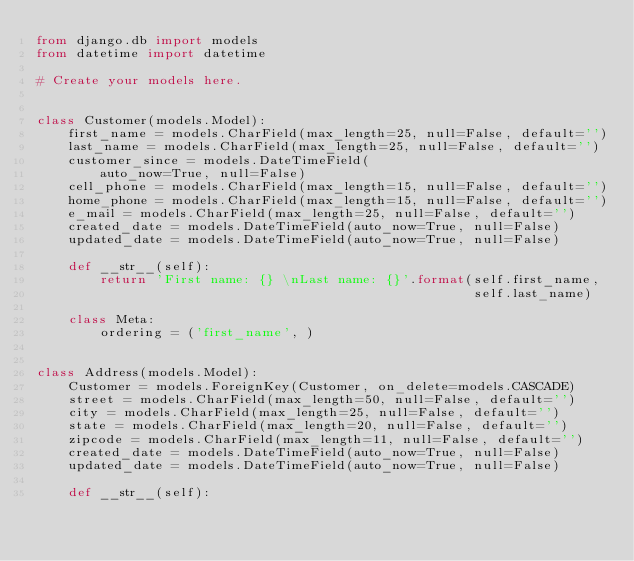<code> <loc_0><loc_0><loc_500><loc_500><_Python_>from django.db import models
from datetime import datetime

# Create your models here.


class Customer(models.Model):
    first_name = models.CharField(max_length=25, null=False, default='')
    last_name = models.CharField(max_length=25, null=False, default='')
    customer_since = models.DateTimeField(
        auto_now=True, null=False)
    cell_phone = models.CharField(max_length=15, null=False, default='')
    home_phone = models.CharField(max_length=15, null=False, default='')
    e_mail = models.CharField(max_length=25, null=False, default='')
    created_date = models.DateTimeField(auto_now=True, null=False)
    updated_date = models.DateTimeField(auto_now=True, null=False)

    def __str__(self):
        return 'First name: {} \nLast name: {}'.format(self.first_name,
                                                       self.last_name)

    class Meta:
        ordering = ('first_name', )


class Address(models.Model):
    Customer = models.ForeignKey(Customer, on_delete=models.CASCADE)
    street = models.CharField(max_length=50, null=False, default='')
    city = models.CharField(max_length=25, null=False, default='')
    state = models.CharField(max_length=20, null=False, default='')
    zipcode = models.CharField(max_length=11, null=False, default='')
    created_date = models.DateTimeField(auto_now=True, null=False)
    updated_date = models.DateTimeField(auto_now=True, null=False)

    def __str__(self):</code> 